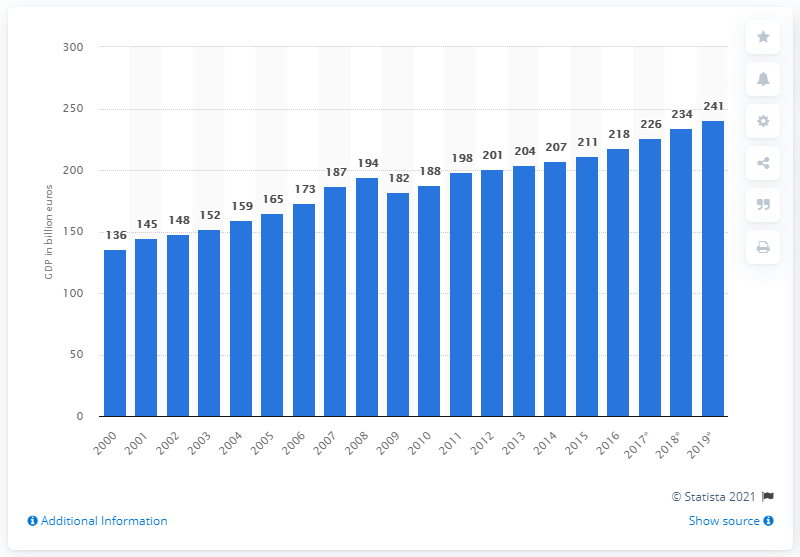Indicate a few pertinent items in this graphic. In 2019, Finland's Gross Domestic Product (GDP) was 241 billion U.S. dollars. The global financial crisis impacted Finland's economy in 2009. 